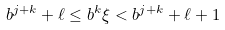Convert formula to latex. <formula><loc_0><loc_0><loc_500><loc_500>b ^ { j + k } + \ell \leq b ^ { k } \xi < b ^ { j + k } + \ell + 1</formula> 